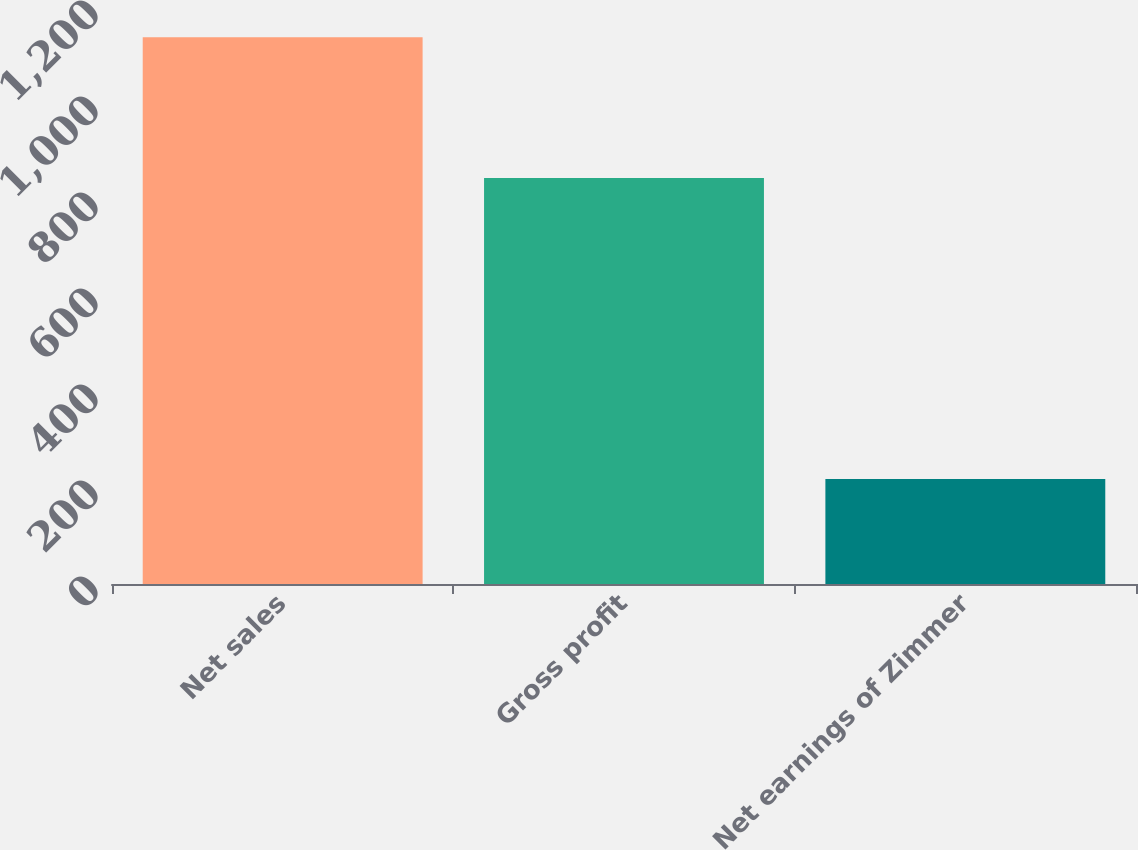Convert chart to OTSL. <chart><loc_0><loc_0><loc_500><loc_500><bar_chart><fcel>Net sales<fcel>Gross profit<fcel>Net earnings of Zimmer<nl><fcel>1138.9<fcel>846<fcel>218.6<nl></chart> 